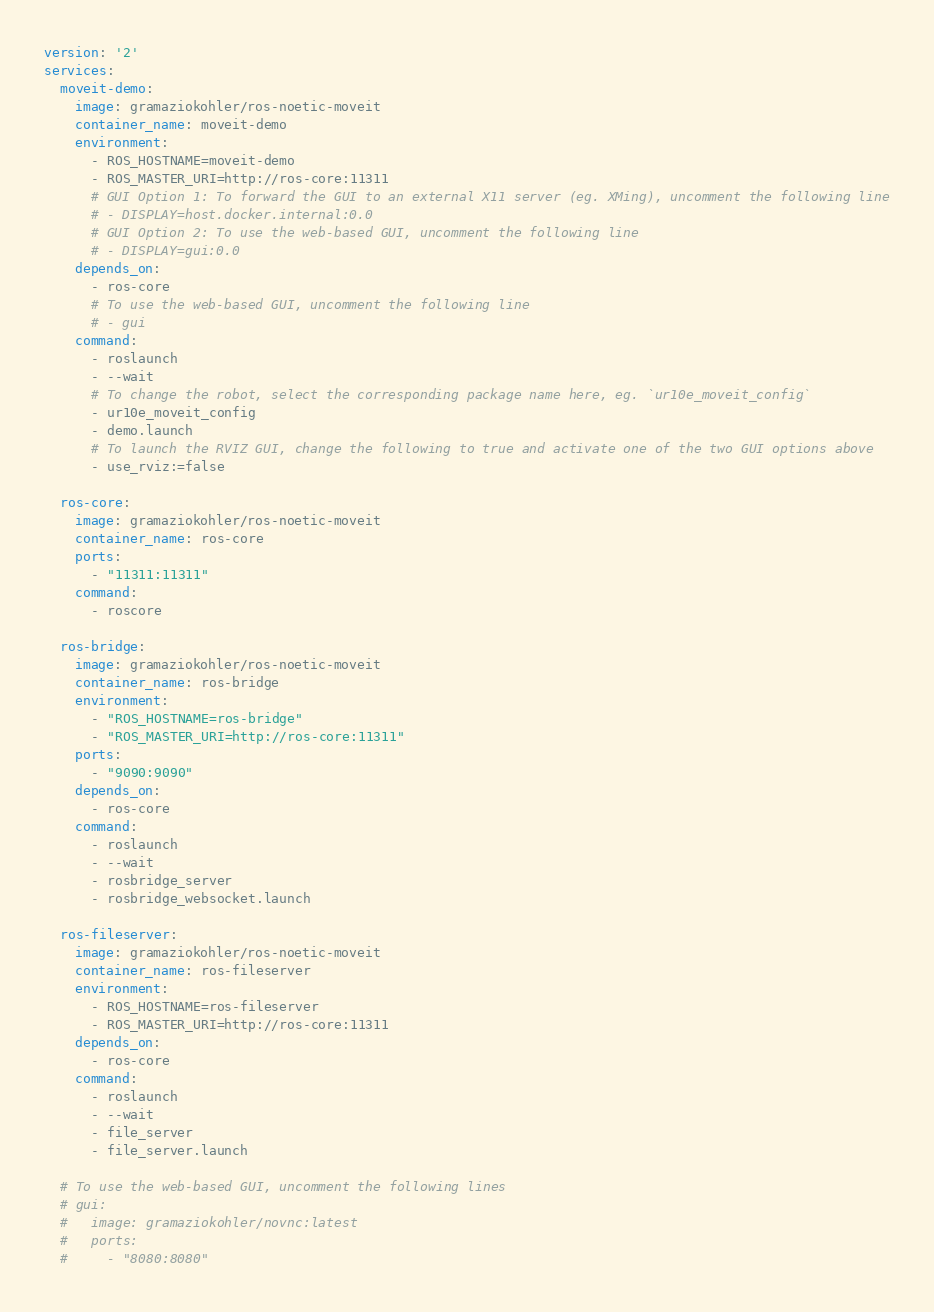Convert code to text. <code><loc_0><loc_0><loc_500><loc_500><_YAML_>version: '2'
services:
  moveit-demo:
    image: gramaziokohler/ros-noetic-moveit
    container_name: moveit-demo
    environment:
      - ROS_HOSTNAME=moveit-demo
      - ROS_MASTER_URI=http://ros-core:11311
      # GUI Option 1: To forward the GUI to an external X11 server (eg. XMing), uncomment the following line
      # - DISPLAY=host.docker.internal:0.0
      # GUI Option 2: To use the web-based GUI, uncomment the following line
      # - DISPLAY=gui:0.0
    depends_on:
      - ros-core
      # To use the web-based GUI, uncomment the following line
      # - gui
    command:
      - roslaunch
      - --wait
      # To change the robot, select the corresponding package name here, eg. `ur10e_moveit_config`
      - ur10e_moveit_config
      - demo.launch
      # To launch the RVIZ GUI, change the following to true and activate one of the two GUI options above
      - use_rviz:=false

  ros-core:
    image: gramaziokohler/ros-noetic-moveit
    container_name: ros-core
    ports:
      - "11311:11311"
    command:
      - roscore

  ros-bridge:
    image: gramaziokohler/ros-noetic-moveit
    container_name: ros-bridge
    environment:
      - "ROS_HOSTNAME=ros-bridge"
      - "ROS_MASTER_URI=http://ros-core:11311"
    ports:
      - "9090:9090"
    depends_on:
      - ros-core
    command:
      - roslaunch
      - --wait
      - rosbridge_server
      - rosbridge_websocket.launch

  ros-fileserver:
    image: gramaziokohler/ros-noetic-moveit
    container_name: ros-fileserver
    environment:
      - ROS_HOSTNAME=ros-fileserver
      - ROS_MASTER_URI=http://ros-core:11311
    depends_on:
      - ros-core
    command:
      - roslaunch
      - --wait
      - file_server
      - file_server.launch

  # To use the web-based GUI, uncomment the following lines
  # gui:
  #   image: gramaziokohler/novnc:latest
  #   ports:
  #     - "8080:8080"
</code> 